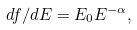Convert formula to latex. <formula><loc_0><loc_0><loc_500><loc_500>d f / d E = E _ { 0 } E ^ { - \alpha } ,</formula> 